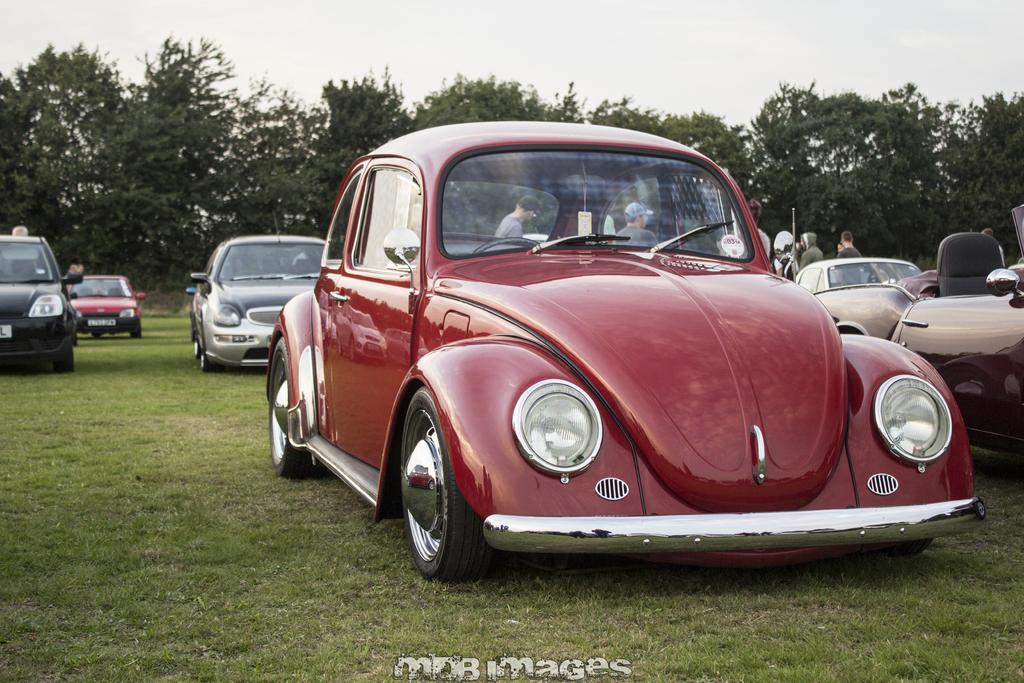What type of vehicles can be seen in the image? There are cars in the image. What natural element is present in the middle of the image? There are trees in the middle of the image. What is visible at the top of the image? The sky is visible at the top of the image. What account number is associated with the car in the image? There is no account number associated with the car in the image, as it is a photograph and not a financial transaction. 